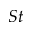Convert formula to latex. <formula><loc_0><loc_0><loc_500><loc_500>S t</formula> 